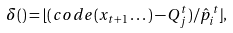<formula> <loc_0><loc_0><loc_500><loc_500>\delta ( ) = \lfloor ( c o d e ( x _ { t + 1 } \dots ) - Q ^ { t } _ { j } ) / \hat { p } _ { i } ^ { \, t } \rfloor ,</formula> 